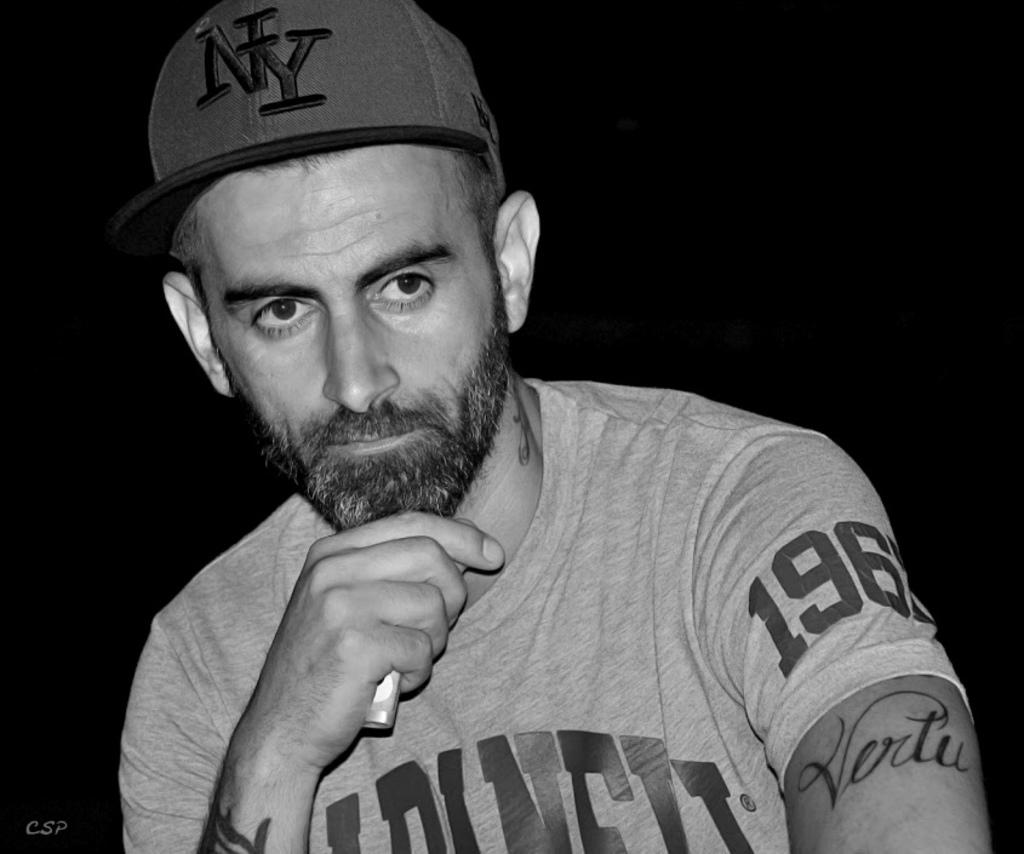What is the color scheme of the image? The image is black and white. Can you describe the person in the image? The person is wearing a cap and has tattoos on their hands and neck. What is the person holding in the image? The person is holding an object. What is the background of the image like? The background of the image is dark. Is there any additional information or markings in the image? Yes, there is a watermark in the image. How many cattle are present in the image? There are no cattle present in the image. What type of sweater is the person wearing in the image? The person is not wearing a sweater in the image; they are wearing a cap. 